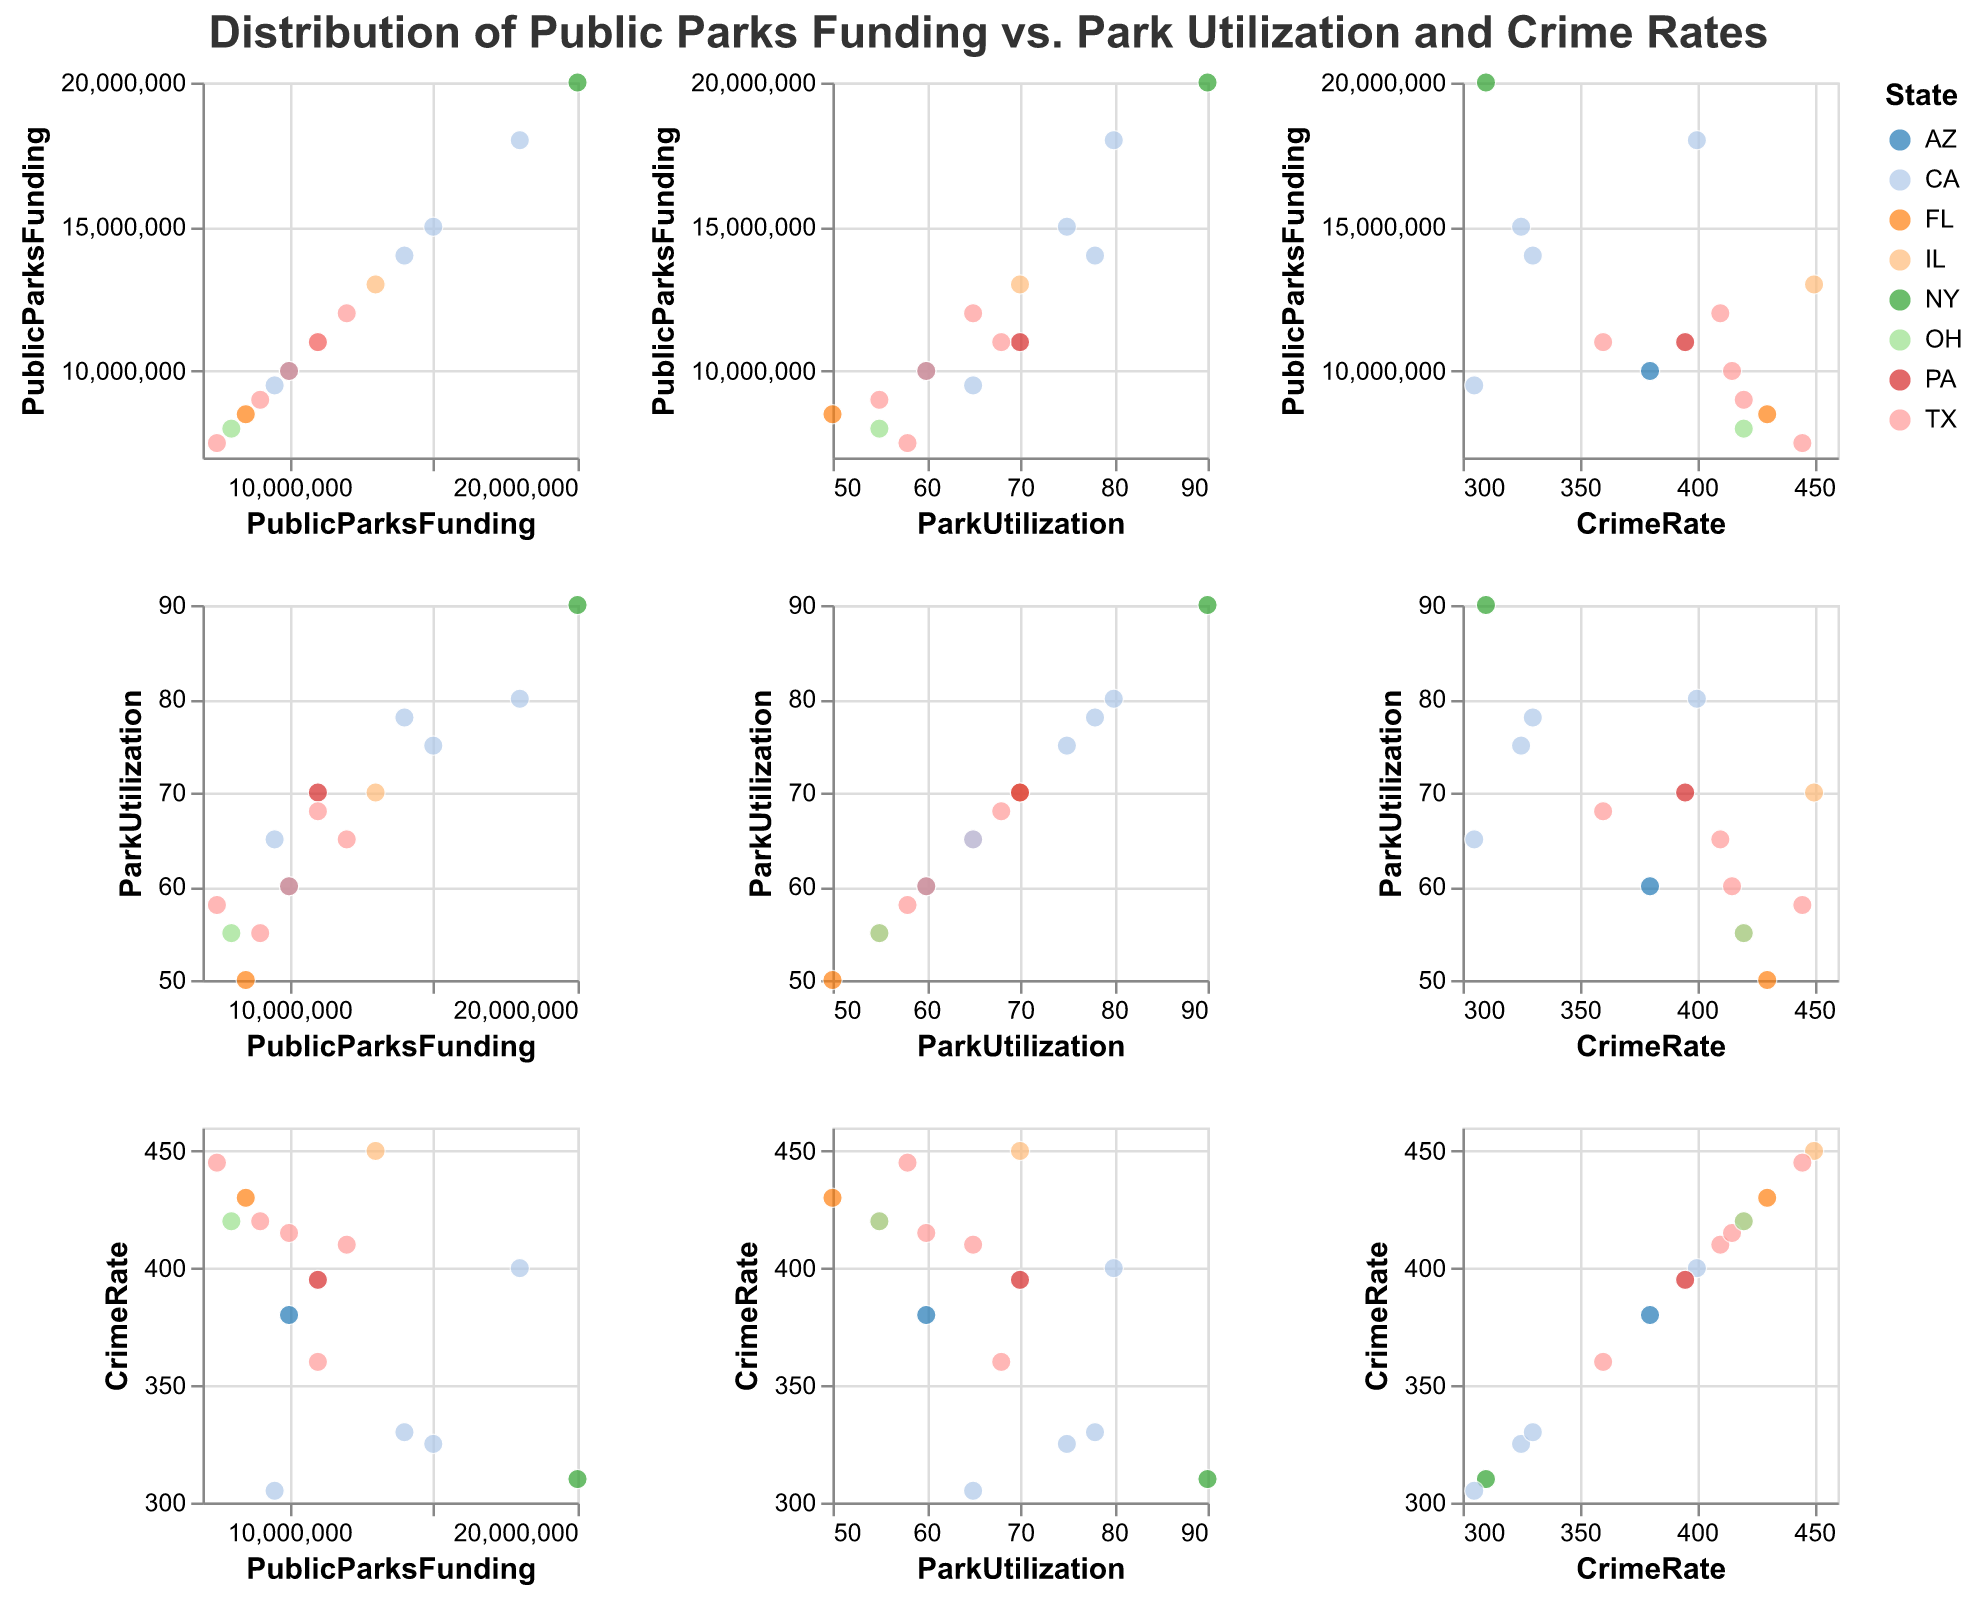What is the title of the figure? The title is typically displayed at the top of the figure. Here, it is "Distribution of Public Parks Funding vs. Park Utilization and Crime Rates," as noted in the description of the code generating the figure.
Answer: Distribution of Public Parks Funding vs. Park Utilization and Crime Rates Which state appears most frequently in the scatter plot matrix? By looking at the color coding in the legend and the data points, we can count how many times each state appears. States that appear the most will have the most data points in the scatter plot matrix.
Answer: TX How many data points are there in total? By counting the number of rows with data in the table, we see that there are 15 data points in total. Each city represents one data point.
Answer: 15 Is there a visible trend between Public Parks Funding and Crime Rates? By examining the scatter plot section where Crime Rate is plotted against Public Parks Funding, we can look for a visible upward or downward trend in the data points. It appears there is no clear trend visible.
Answer: No clear trend What is the range of Park Utilization percentages across all cities? We need to find the minimum and maximum values for Park Utilization from the data. The minimum value is 50%, and the maximum value is 90%. The range can be found by subtracting the minimum from the maximum.
Answer: 40% Which city has the highest Public Parks Funding? We need to look for the data point with the highest value on the Public Parks Funding axis. From the data, New York has the highest Public Parks Funding of $20,000,000.
Answer: New York Compare the Crime Rates of San Francisco and Los Angeles. Which city has a higher Crime Rate? By examining the data points for both cities, we can see that San Francisco has a Crime Rate of 325, and Los Angeles has a Crime Rate of 400. Thus, Los Angeles has a higher Crime Rate.
Answer: Los Angeles What is the relationship between Park Utilization and Crime Rate for cities with Public Parks Funding greater than $15,000,000? We need to find cities with Public Parks Funding above $15,000,000 and compare their Park Utilization and Crime Rates. From the data, San Francisco (75%, 325), Los Angeles (80%, 400), and New York (90%, 310) are such cities, showing varying correlations without a consistent pattern.
Answer: Variable relationship What is the average Crime Rate of the cities with Public Parks Funding less than or equal to $10,000,000? We identify the cities first: Phoenix, San Antonio, Dallas, San Jose, Jacksonville, Fort Worth, and Columbus. Their Crime Rates are 380, 420, 415, 305, 430, 445, and 420 respectively. The sum of these values is 2715. We divide by the number of cities (7) to find the average Crime Rate.
Answer: 387.86 Are there any outliers among the points representing Park Utilization vs. Crime Rate? By examining the scatter plot portion of Park Utilization vs. Crime Rate, an outlier would be a point that deviates significantly from the overall pattern. Chicago, with a Crime Rate of 450 and Park Utilization of 70, seems significantly higher compared to other points.
Answer: Yes (Chicago) 